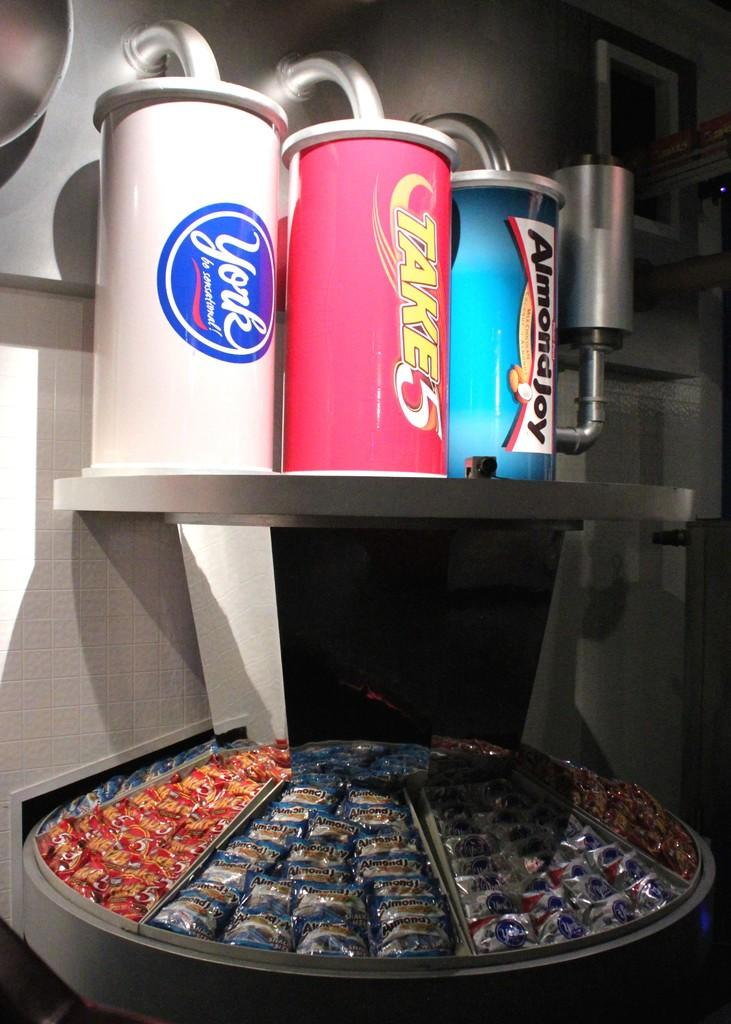<image>
Provide a brief description of the given image. Some containers in white, blue and pink, the pink one has the word Take on it. 